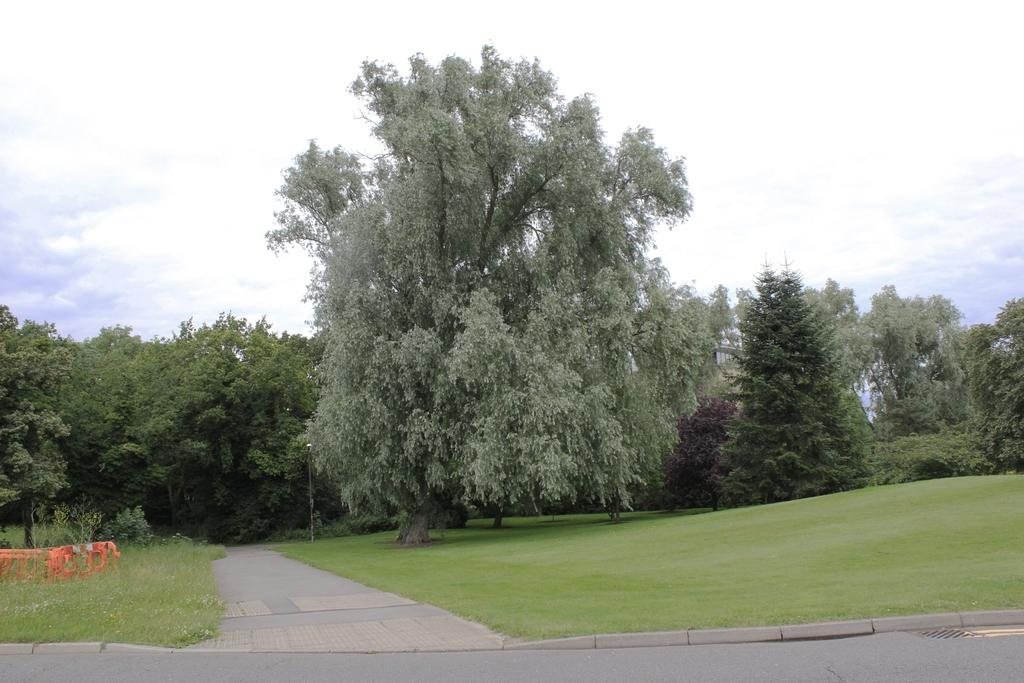What type of pathway is present in the image? There is a road in the image. What type of vegetation can be seen on the ground in the image? There is grass on the ground in the image. What is the direction of the road visible in the image? The way is visible in the image. What type of natural elements are present in the image? There are trees in the image. What is visible at the top of the image? The sky is visible at the top of the image. What type of drum can be heard playing in the image? There is no drum present or audible in the image; it is a visual representation without sound. 